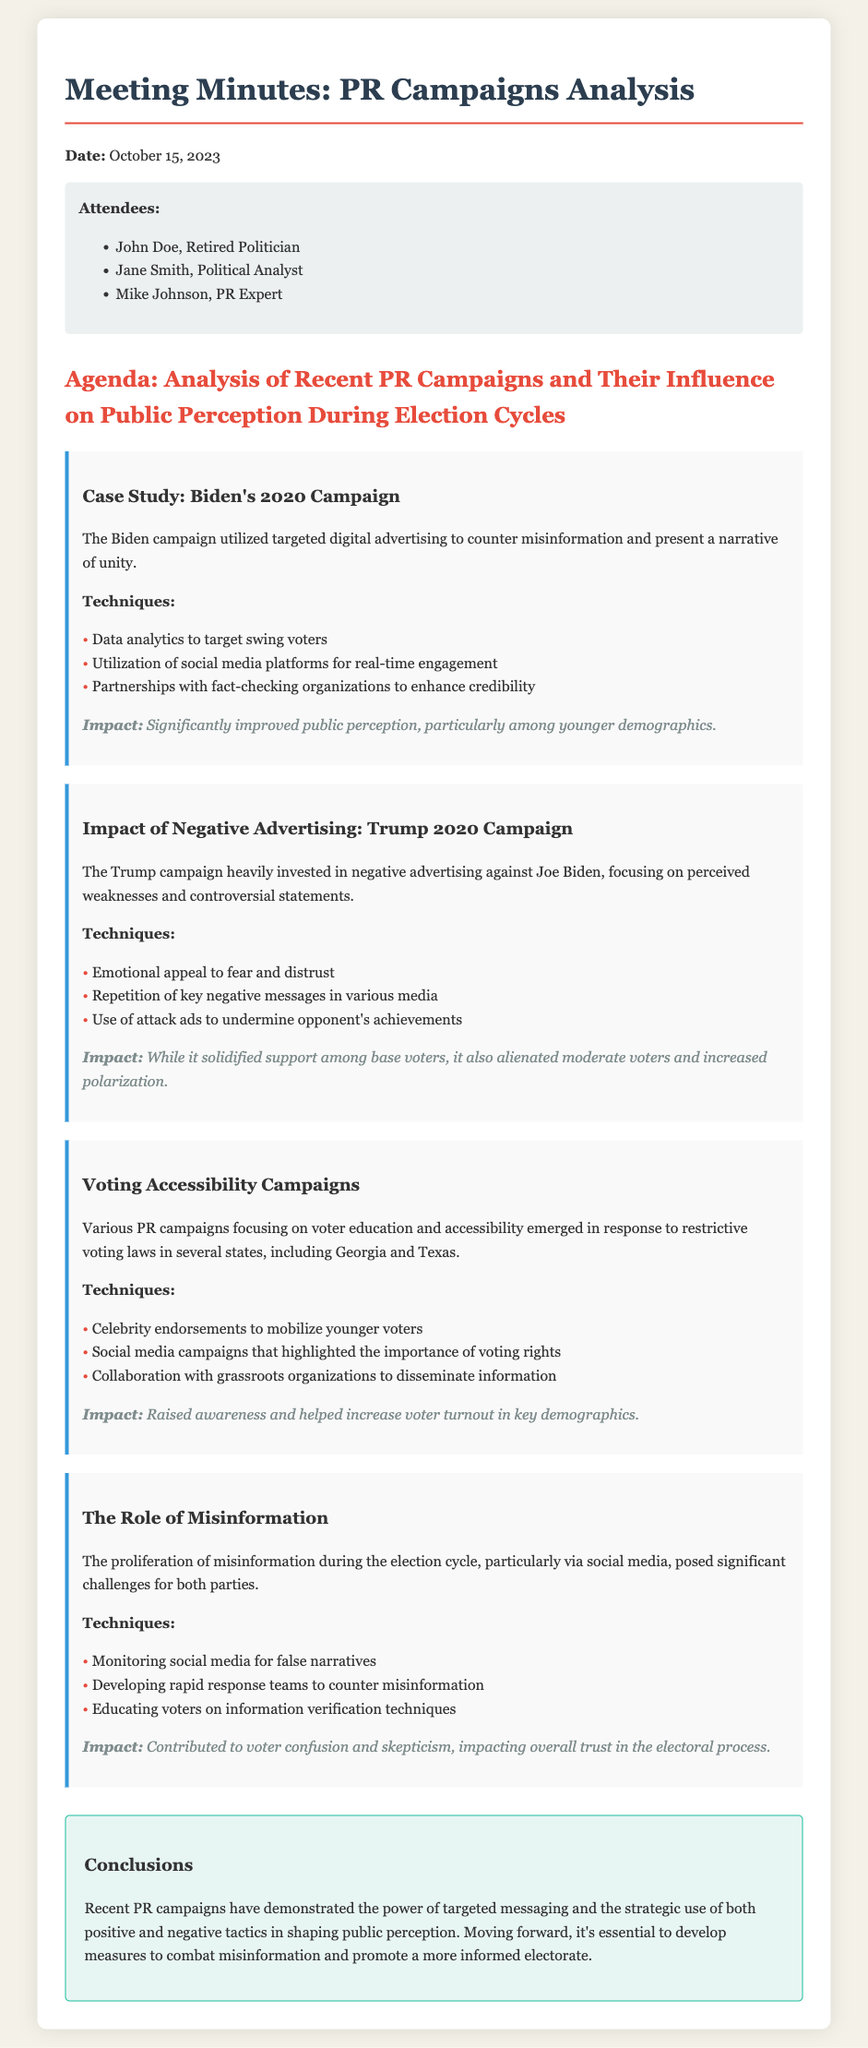What is the date of the meeting? The date is specified at the top of the document.
Answer: October 15, 2023 Who were the attendees present at the meeting? The attendees are listed under the attendees section.
Answer: John Doe, Jane Smith, Mike Johnson What campaign is used as a case study in the document? The document highlights a specific campaign for detailed analysis.
Answer: Biden's 2020 Campaign What technique was utilized by the Biden campaign for countering misinformation? The document lists specific techniques used in the campaign.
Answer: Partnerships with fact-checking organizations What was the impact of Trump's negative advertising? The document outlines the effects of the advertising strategy employed.
Answer: Alienated moderate voters and increased polarization Which demographic did the voting accessibility campaigns aim to mobilize? The document mentions a specific group targeted by the campaigns.
Answer: Younger voters What role did social media play in the proliferation of misinformation? The document discusses the challenges related to misinformation.
Answer: Significant challenges for both parties What is the conclusion regarding the impact of recent PR campaigns? The document summarizes the findings about PR campaigns.
Answer: Power of targeted messaging and strategic use of tactics 